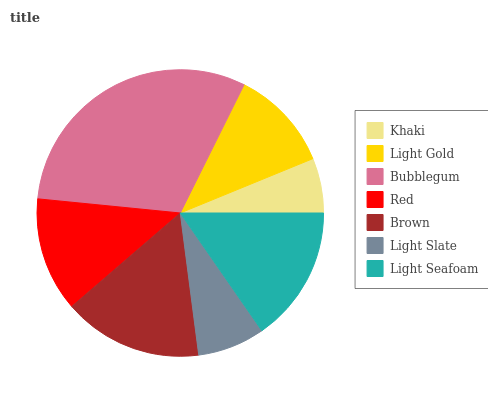Is Khaki the minimum?
Answer yes or no. Yes. Is Bubblegum the maximum?
Answer yes or no. Yes. Is Light Gold the minimum?
Answer yes or no. No. Is Light Gold the maximum?
Answer yes or no. No. Is Light Gold greater than Khaki?
Answer yes or no. Yes. Is Khaki less than Light Gold?
Answer yes or no. Yes. Is Khaki greater than Light Gold?
Answer yes or no. No. Is Light Gold less than Khaki?
Answer yes or no. No. Is Red the high median?
Answer yes or no. Yes. Is Red the low median?
Answer yes or no. Yes. Is Bubblegum the high median?
Answer yes or no. No. Is Brown the low median?
Answer yes or no. No. 